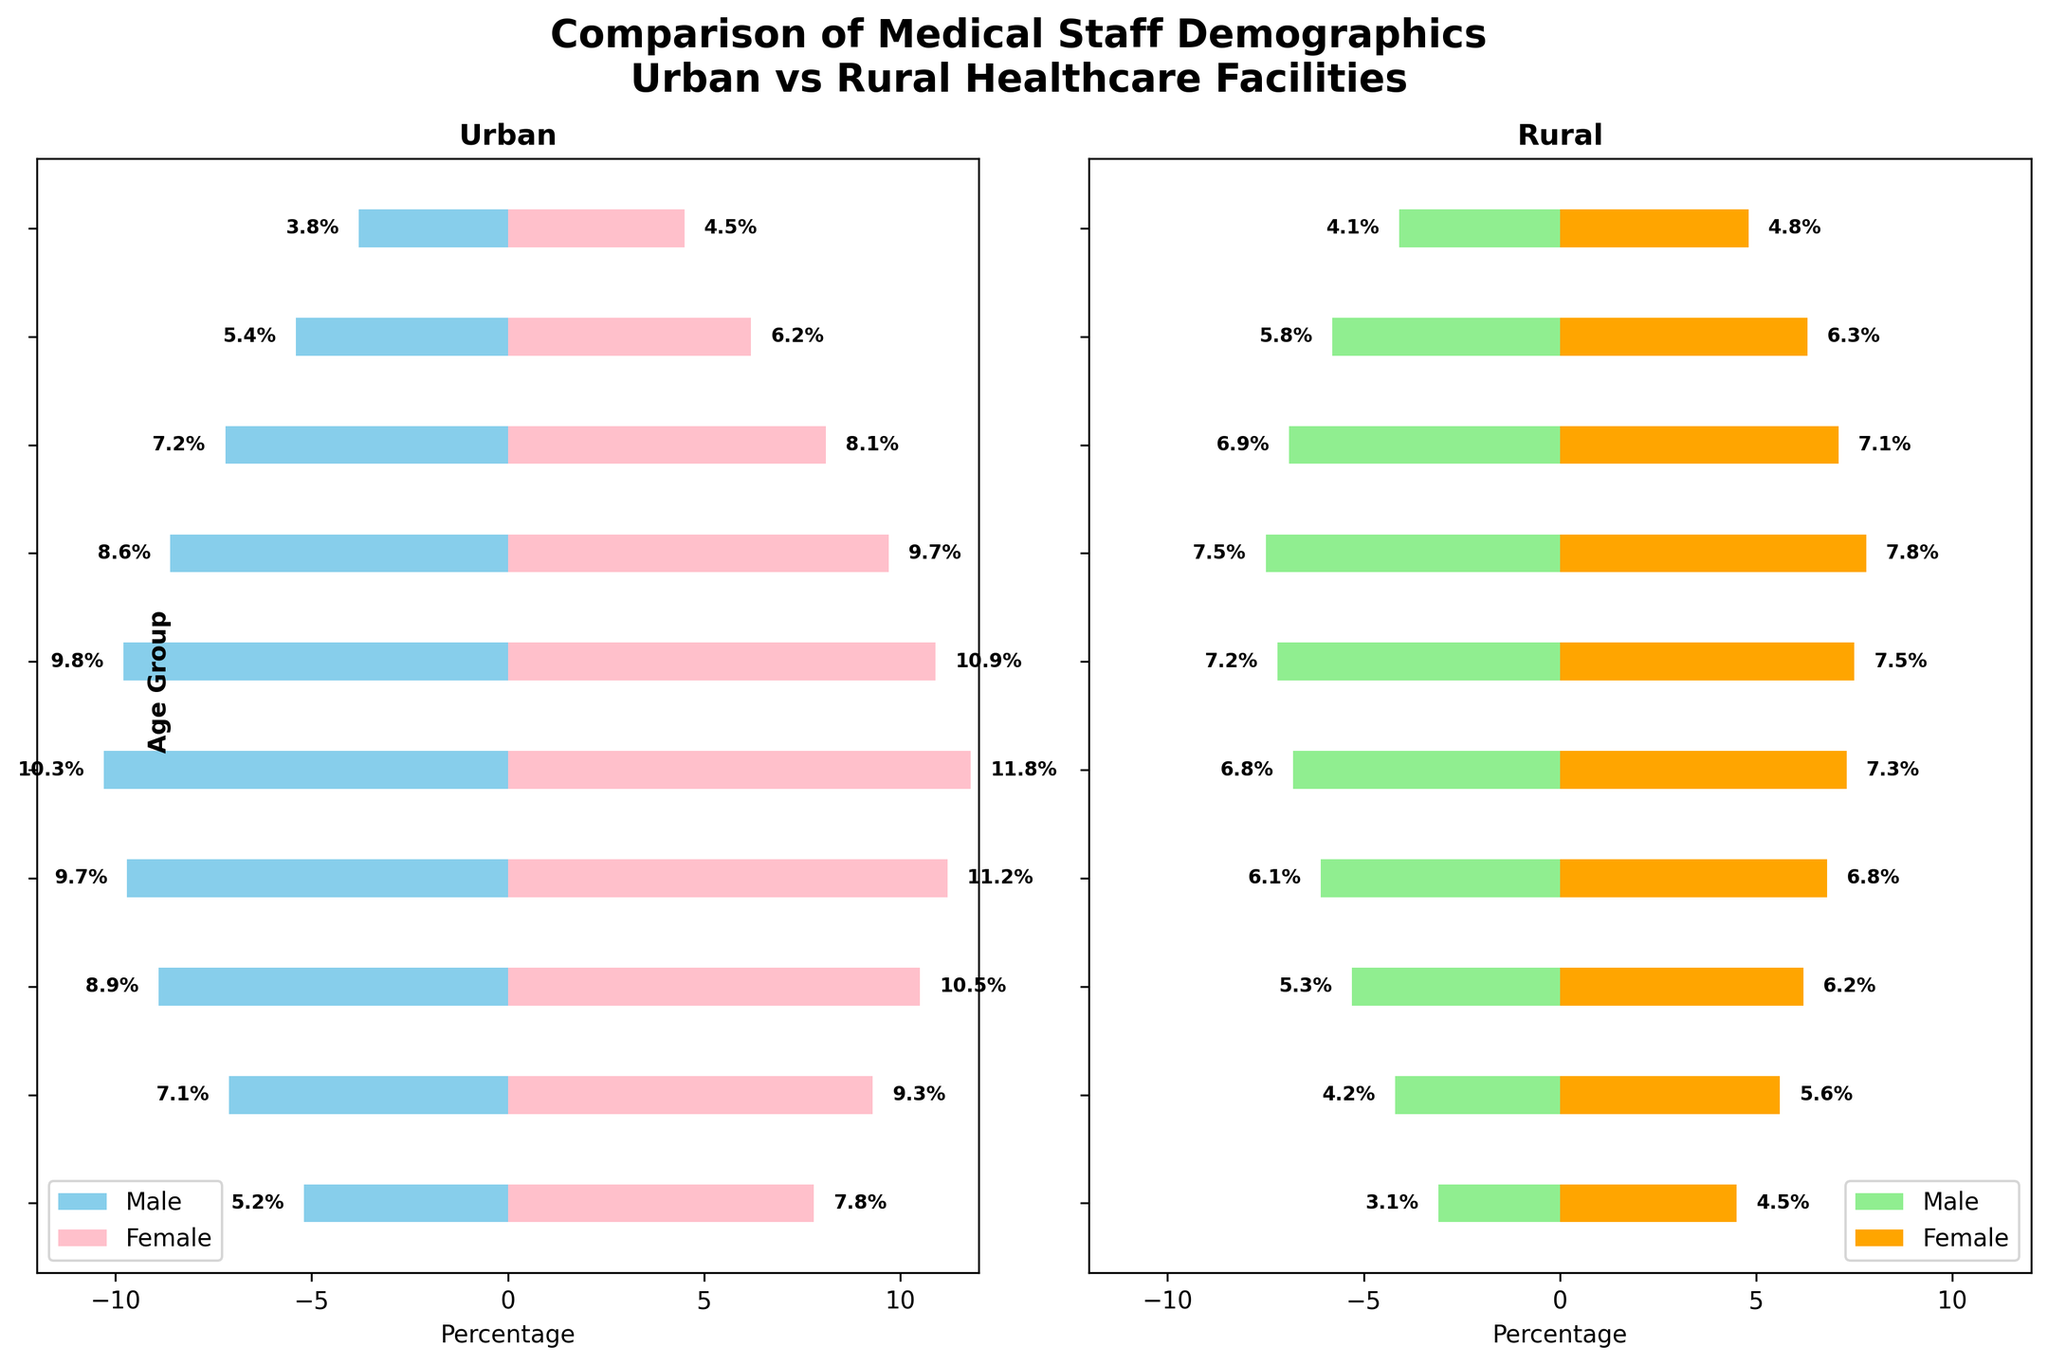What is the title of the figure? The title is written at the top of the figure in bold, indicating what the plot represents.
Answer: Comparison of Medical Staff Demographics: Urban vs Rural Healthcare Facilities Which age group has the highest percentage of urban male medical staff? Look at the bars for urban male in each age group and identify the longest bar.
Answer: 40-44 In the 50-54 age group, which has a higher percentage: rural male or rural female medical staff? Compare the lengths of the bars for rural male and rural female within the 50-54 age group.
Answer: Rural Female What is the combined percentage of female medical staff (urban and rural) in the 65+ age group? Add the percentages of urban female (4.5) and rural female (4.8) in the 65+ age group: 4.5 + 4.8.
Answer: 9.3% How does the percentage of urban female medical staff in the 35-39 age group compare to the percentage of rural female medical staff in the same age group? Identify the bars for urban and rural females in the 35-39 age group and compare their lengths.
Answer: Urban Female is higher Which age group shows the smallest difference between the percentages of urban male and rural male medical staff? Calculate the absolute difference between urban male and rural male percentages for each age group, and identify the smallest value.
Answer: 20-24 Calculate the average percentage of medical staff (male and female combined) for the 30-34 age group across both urban and rural facilities. Add the percentages of urban male, urban female, rural male, and rural female in the 30-34 age group: 8.9 + 10.5 + 5.3 + 6.2, then divide by 4.
Answer: 7.725% How do the profiles of urban male and rural male medical staff distributions compare across all age groups? Observe the lengths of the bars for urban and rural males across all age groups to establish trends or noticeable differences.
Answer: Urban male percentages are generally higher across most age groups What is the least populated age group for rural female medical staff? Identify the smallest bar among rural female age groups.
Answer: 20-24 In the 45-49 age group, what is the percentage difference between urban female and rural female medical staff? Subtract the percentage of rural female (7.5) from the percentage of urban female (10.9) in the 45-49 age group: 10.9 - 7.5.
Answer: 3.4% 